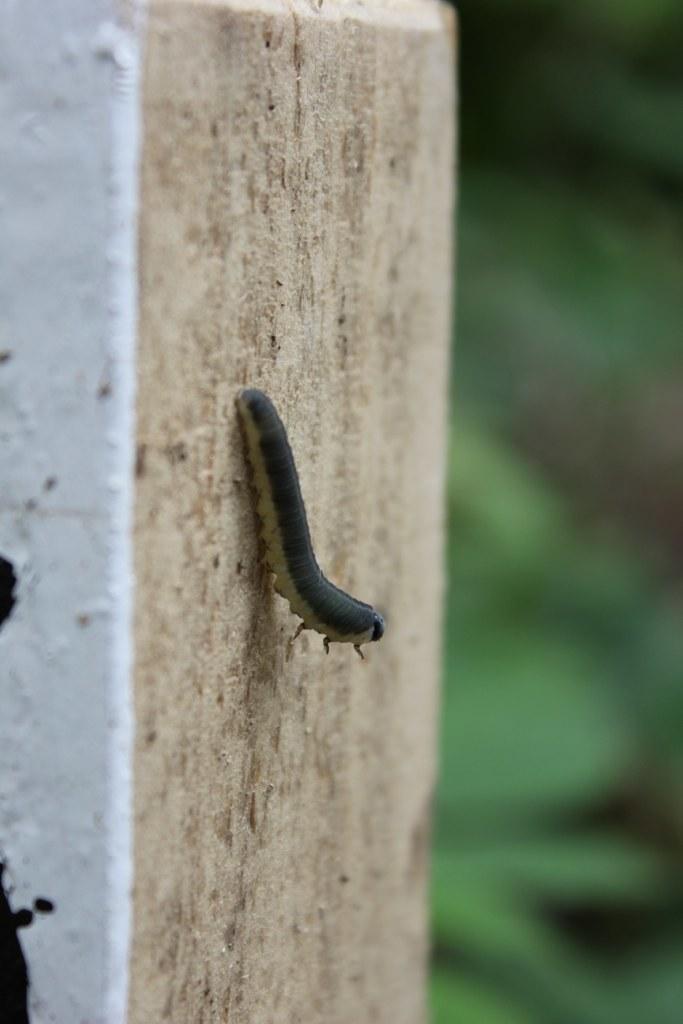In one or two sentences, can you explain what this image depicts? In this image we can see an insect. There is a white and a black color painted on an object. There is a blur background at the right side of the image. 